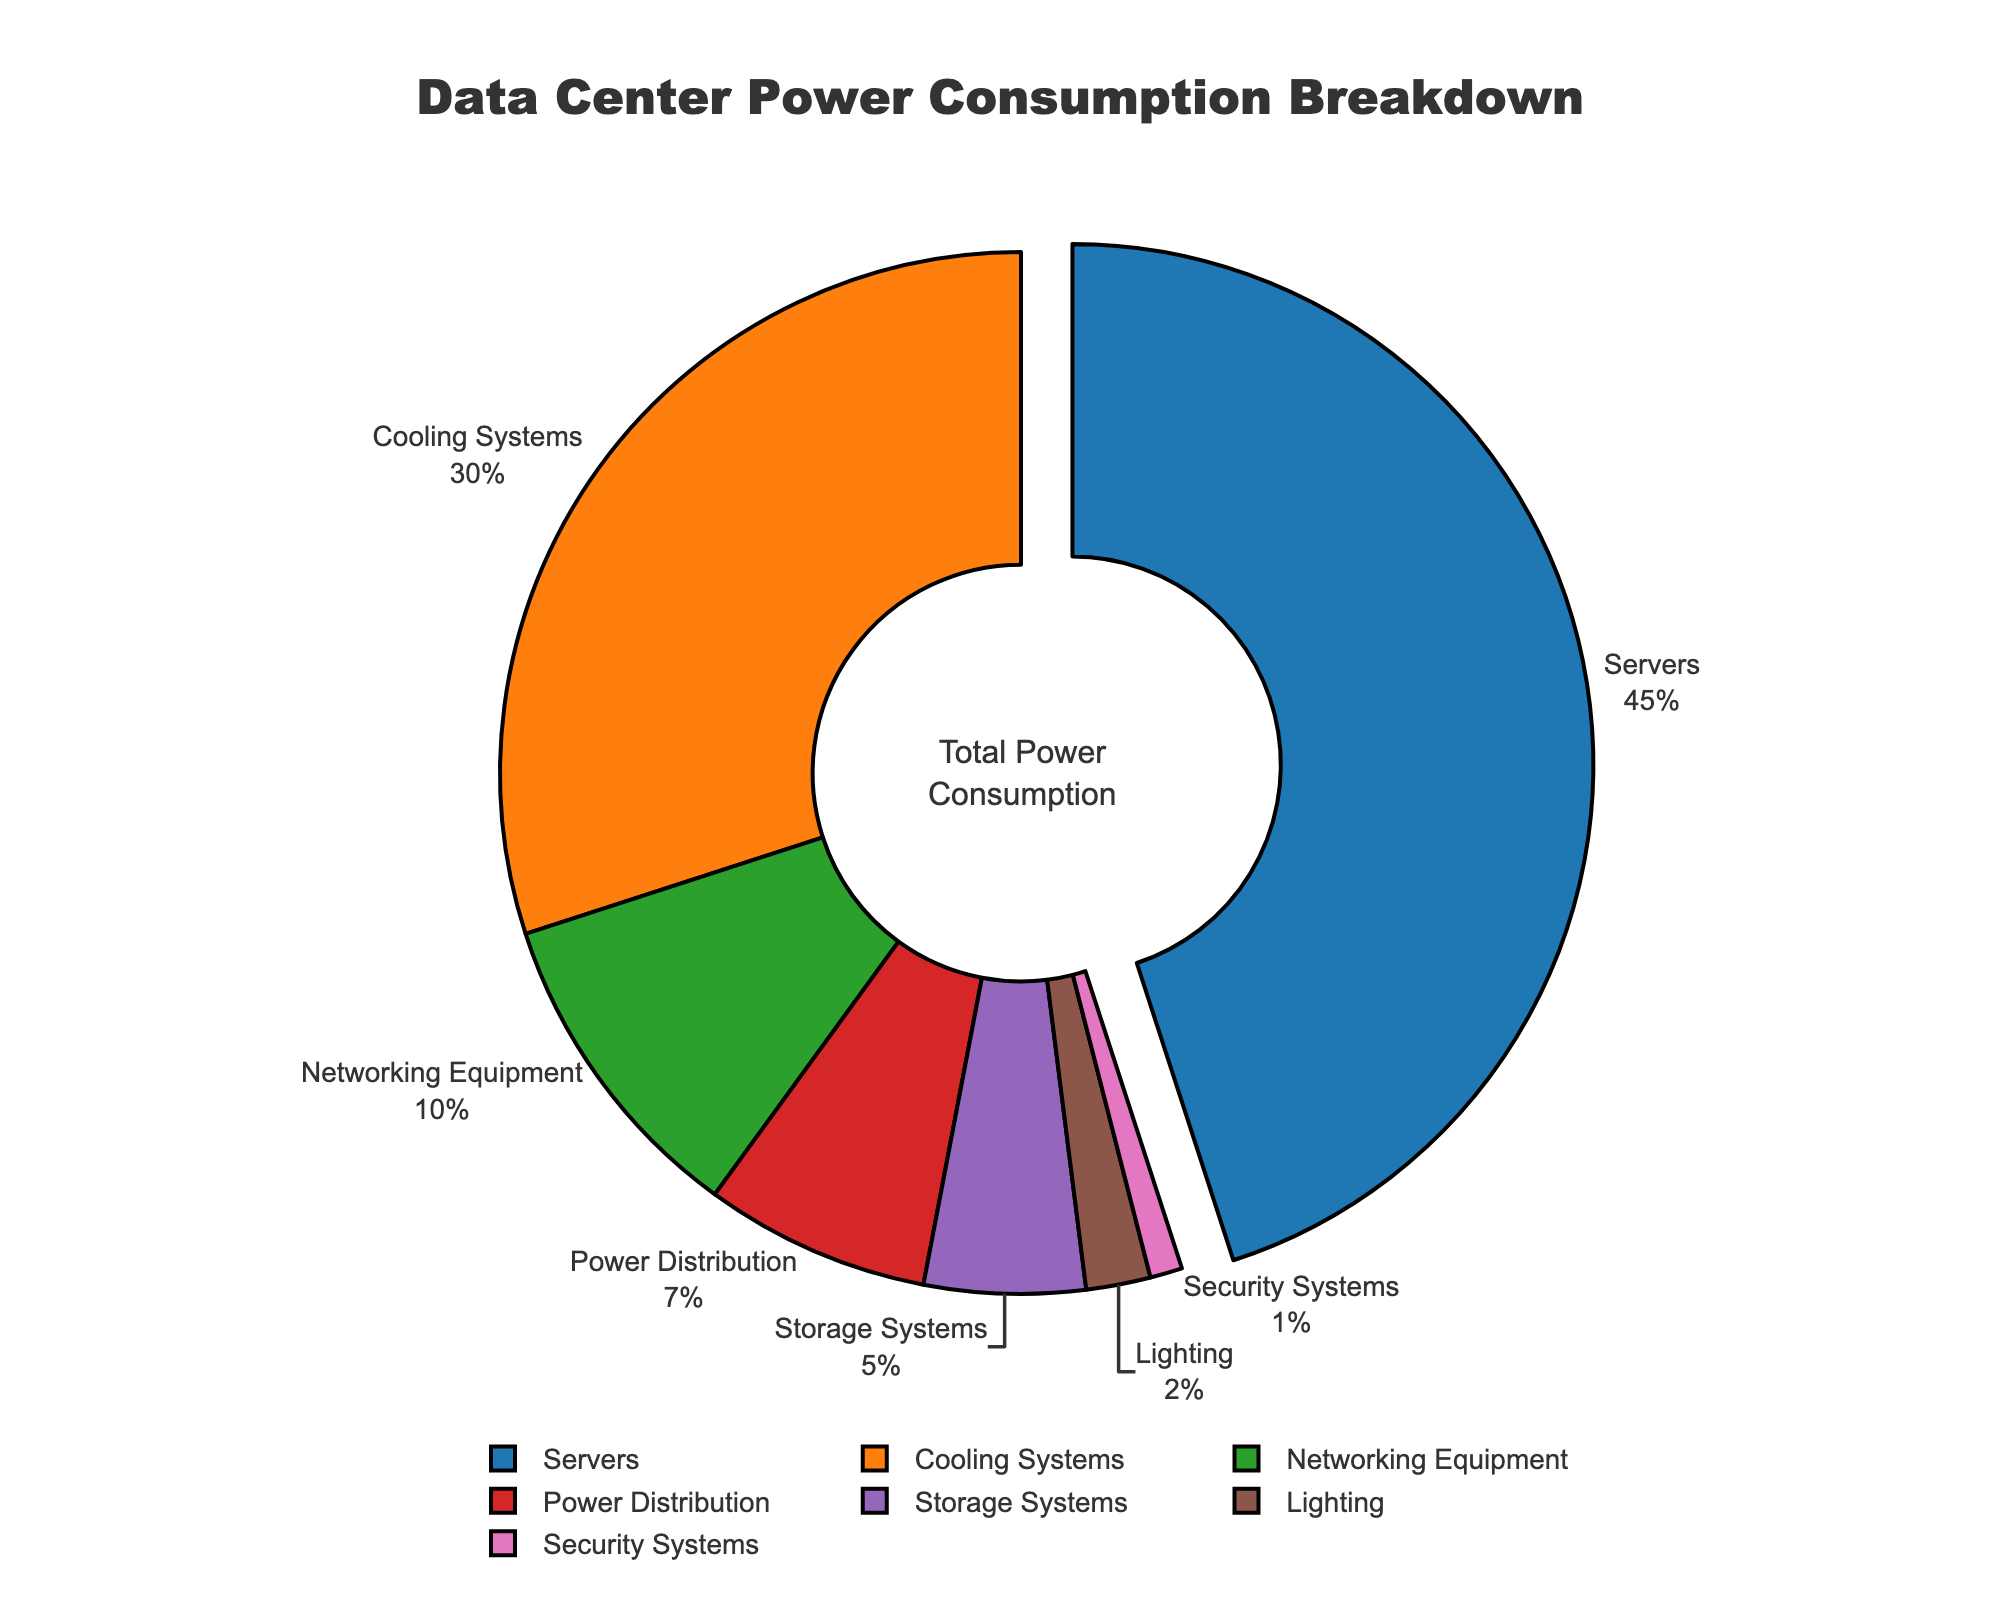What component has the highest power consumption percentage? The servers component consumes 45%, which is the largest slice of the pie chart.
Answer: Servers Which components together consume half of the total power? Servers consume 45% and Cooling Systems consume 30%. Together, they consume 45% + 30% = 75%, which is more than half. Therefore, no two components exactly consume half. But the servers alone consume the highest portion.
Answer: Servers and Cooling Systems How much more power do the servers consume compared to the networking equipment? Servers (45%) - Networking Equipment (10%) = 35%.
Answer: 35% What is the combined power consumption of Storage Systems and Lighting? Storage Systems consume 5% and Lighting consumes 2%. Combined, they consume 5% + 2% = 7%.
Answer: 7% By how much percentage does cooling systems' power consumption exceed the power distribution's power consumption? Cooling Systems consume 30% and Power Distribution consumes 7%. The difference is 30% - 7% = 23%.
Answer: 23% Which component has the least power consumption and what is its percentage? Security Systems have the smallest slice at 1%.
Answer: Security Systems with 1% Compare in terms of power consumption: how do the roles of storage systems and power distribution differ? Storage Systems consume 5% while Power Distribution consumes 7%. Power Distribution consumes 2% more.
Answer: Power Distribution consumes 2% more than Storage Systems Which two components combined have nearly the same power consumption as cooling systems alone? Networking Equipment (10%) + Power Distribution (7%) + Storage Systems (5%) + Lighting (2%) + Security Systems (1%) = 25%. This is compared to Cooling Systems at 30%, so no exact match, but a combination could be Servers (45%) being closer.
Answer: None exactly, but Servers are closest alone What visual cue indicates the component with the highest power consumption on the chart? The pie slice for Servers is pulled slightly away from the center to highlight it as the component with the highest power consumption.
Answer: The pie slice is pulled away What is the total power consumption percentage of all components not including Cooling Systems and Servers? Networking Equipment (10%) + Power Distribution (7%) + Storage Systems (5%) + Lighting (2%) + Security Systems (1%) = 25%.
Answer: 25% 